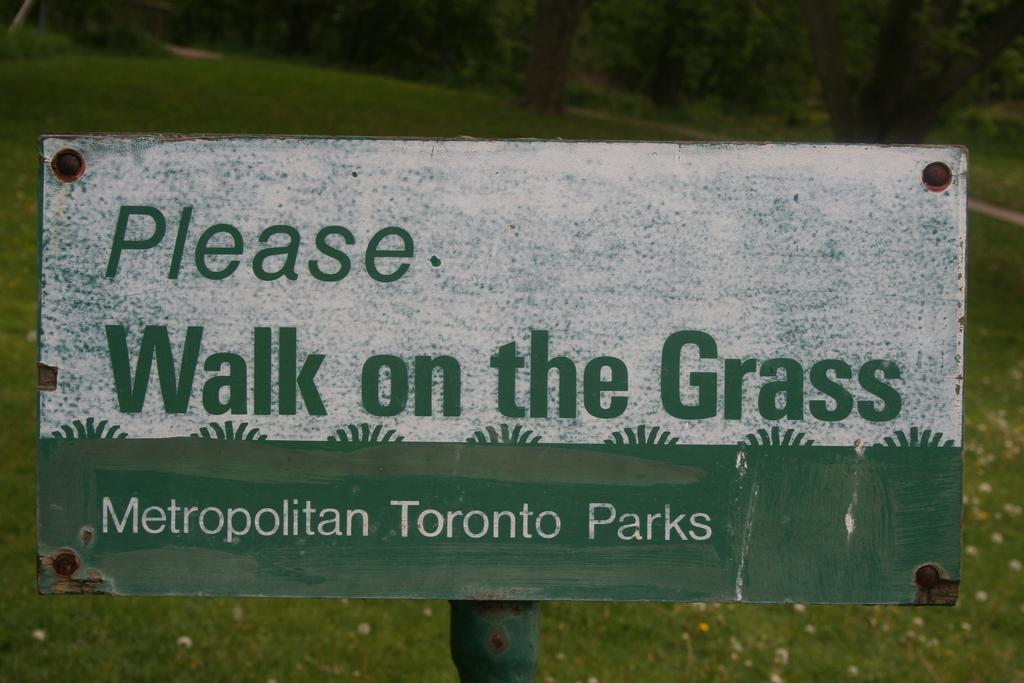What is the main subject of the image? The main subject of the image is a board about the park. Can you describe the background of the image? There is grass visible behind the board. What type of sound can be heard coming from the cakes in the image? There are no cakes present in the image, so it's not possible to determine what, if any, sounds might be heard. 